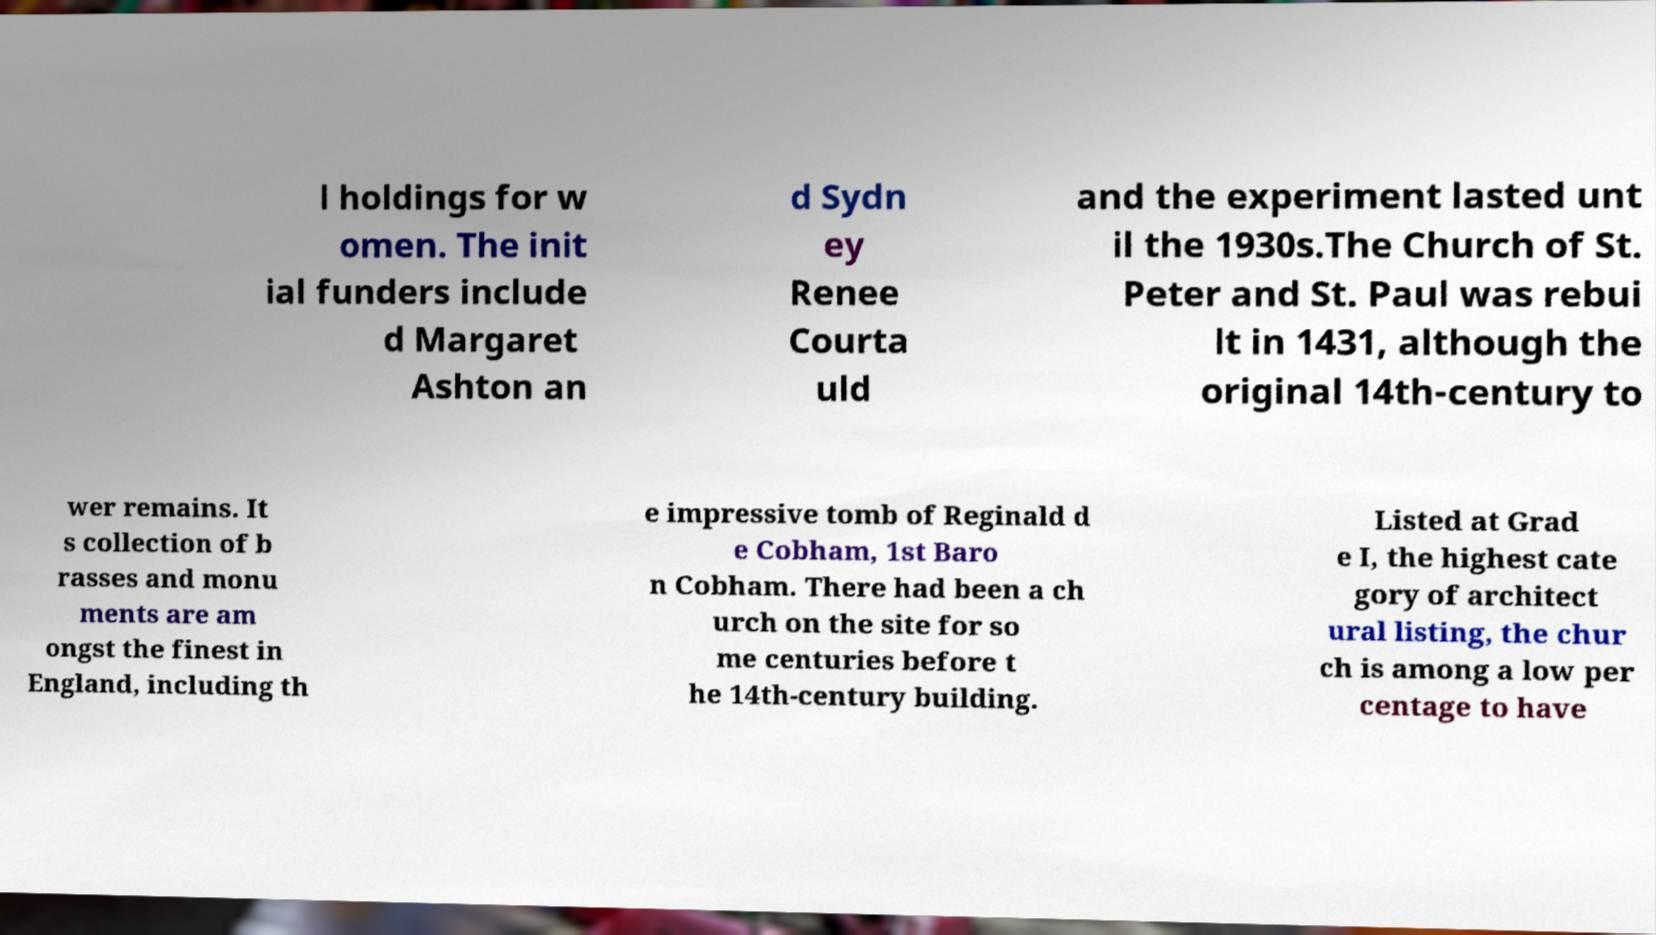Can you read and provide the text displayed in the image?This photo seems to have some interesting text. Can you extract and type it out for me? l holdings for w omen. The init ial funders include d Margaret Ashton an d Sydn ey Renee Courta uld and the experiment lasted unt il the 1930s.The Church of St. Peter and St. Paul was rebui lt in 1431, although the original 14th-century to wer remains. It s collection of b rasses and monu ments are am ongst the finest in England, including th e impressive tomb of Reginald d e Cobham, 1st Baro n Cobham. There had been a ch urch on the site for so me centuries before t he 14th-century building. Listed at Grad e I, the highest cate gory of architect ural listing, the chur ch is among a low per centage to have 